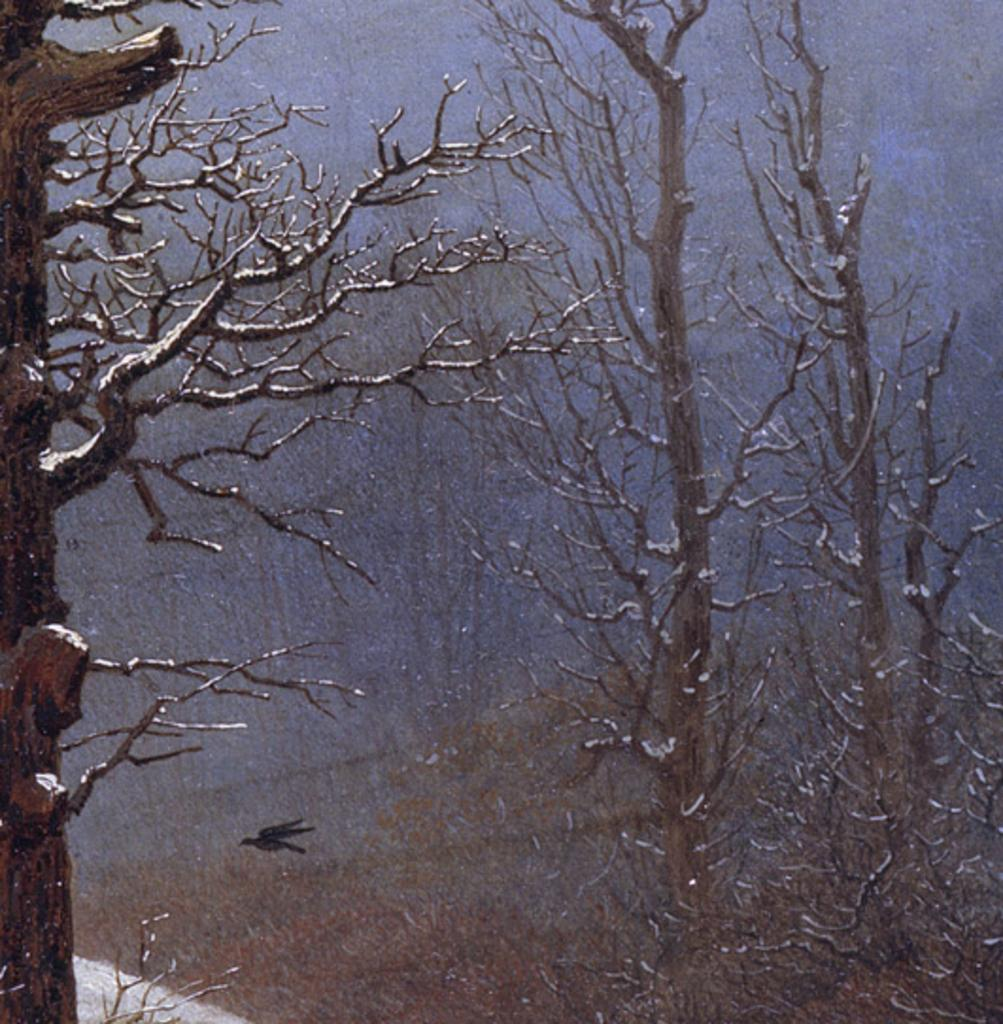What can be seen in the center of the image? The sky is visible in the center of the image. What type of vegetation is present in the image? There are trees in the image. What is the bird in the image doing? A bird is flying in the image. What type of bone can be seen in the image? There is no bone present in the image. How much sugar is visible in the image? There is no sugar present in the image. 